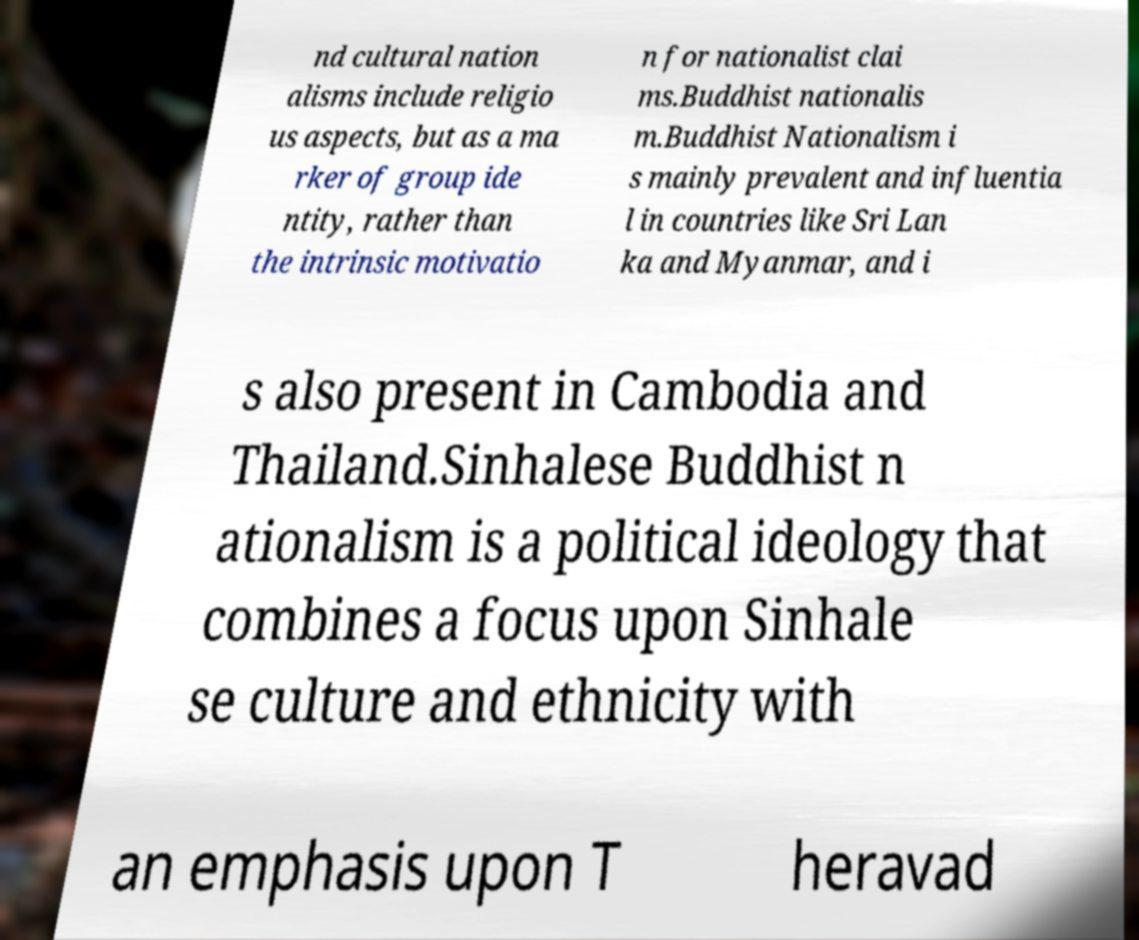There's text embedded in this image that I need extracted. Can you transcribe it verbatim? nd cultural nation alisms include religio us aspects, but as a ma rker of group ide ntity, rather than the intrinsic motivatio n for nationalist clai ms.Buddhist nationalis m.Buddhist Nationalism i s mainly prevalent and influentia l in countries like Sri Lan ka and Myanmar, and i s also present in Cambodia and Thailand.Sinhalese Buddhist n ationalism is a political ideology that combines a focus upon Sinhale se culture and ethnicity with an emphasis upon T heravad 